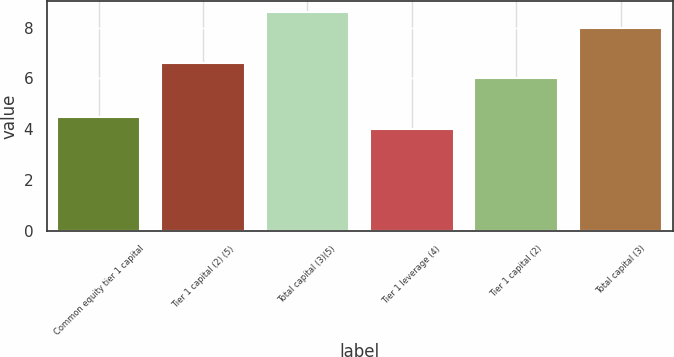Convert chart to OTSL. <chart><loc_0><loc_0><loc_500><loc_500><bar_chart><fcel>Common equity tier 1 capital<fcel>Tier 1 capital (2) (5)<fcel>Total capital (3)(5)<fcel>Tier 1 leverage (4)<fcel>Tier 1 capital (2)<fcel>Total capital (3)<nl><fcel>4.5<fcel>6.62<fcel>8.62<fcel>4<fcel>6<fcel>8<nl></chart> 